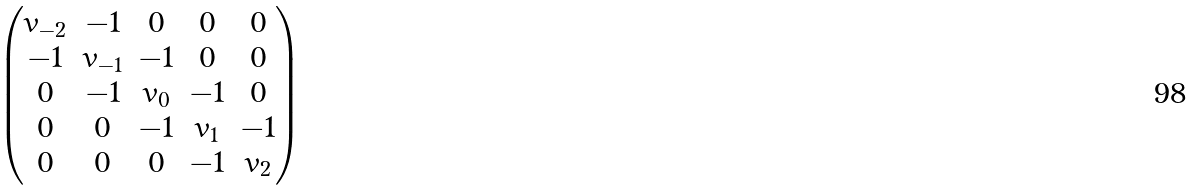Convert formula to latex. <formula><loc_0><loc_0><loc_500><loc_500>\begin{pmatrix} v _ { - 2 } & - 1 & 0 & 0 & 0 \\ - 1 & v _ { - 1 } & - 1 & 0 & 0 \\ 0 & - 1 & v _ { 0 } & - 1 & 0 \\ 0 & 0 & - 1 & v _ { 1 } & - 1 \\ 0 & 0 & 0 & - 1 & v _ { 2 } \end{pmatrix}</formula> 